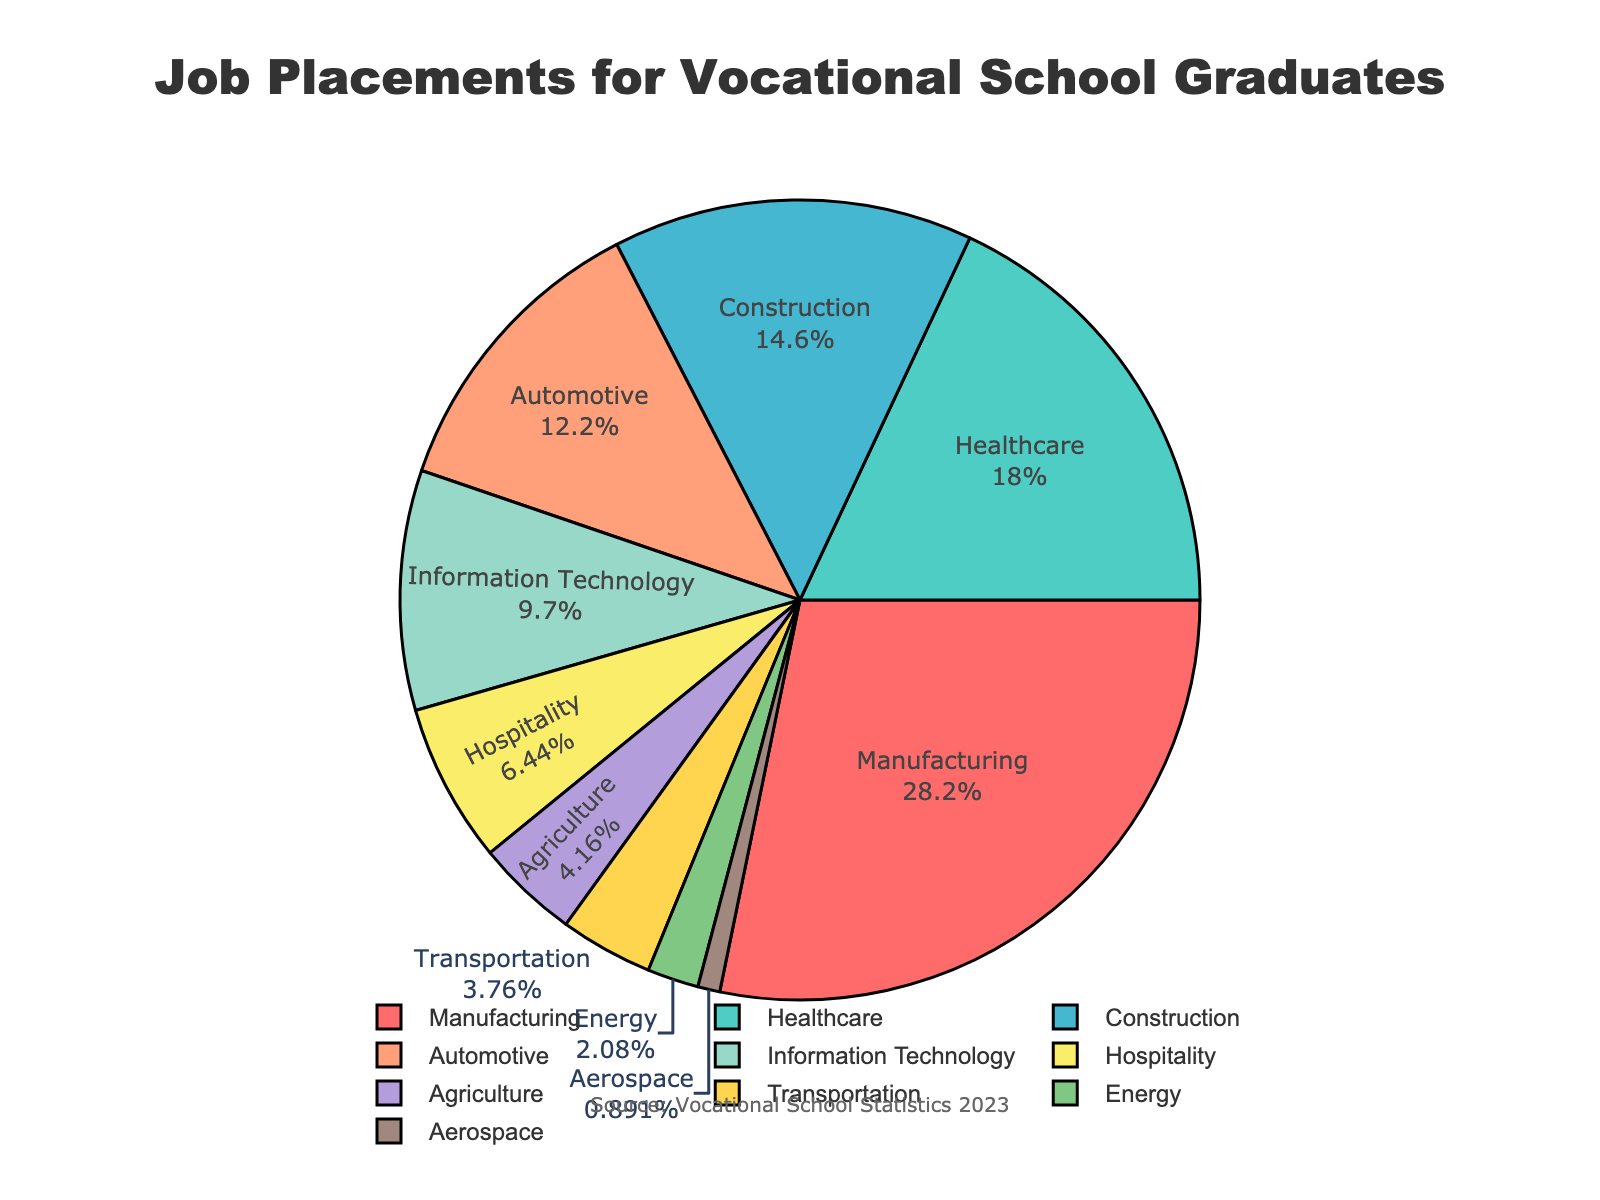What is the largest sector for job placements? The largest sector is identified by the highest percentage in the pie chart. Manufacturing shows the largest slice at 28.5%.
Answer: Manufacturing How many industries have a placement percentage greater than 10%? By looking at the pie chart, we can count the industries with percentages higher than 10%. These are Manufacturing (28.5%), Healthcare (18.2%), Construction (14.7%), and Automotive (12.3%). So, there are 4 industries.
Answer: 4 Which industry has the smallest share of job placements? The smallest sector can be found by identifying the smallest slice in the pie chart. Aerospace shows the smallest slice at 0.9%.
Answer: Aerospace What is the combined percentage of job placements in the Hospitality and Agriculture industries? To get the combined percentage, add the values for Hospitality (6.5%) and Agriculture (4.2%). This sums to 10.7%.
Answer: 10.7% Which sectors have a higher percentage of job placements than Information Technology? The Information Technology sector is at 9.8%. The sectors with higher percentages are Manufacturing (28.5%), Healthcare (18.2%), Construction (14.7%), and Automotive (12.3%).
Answer: Manufacturing, Healthcare, Construction, Automotive What is the difference in job placement percentages between the Manufacturing and Healthcare sectors? Subtract the percentage of Healthcare (18.2%) from Manufacturing (28.5%). The difference is 10.3%.
Answer: 10.3% Rank the top three sectors in terms of job placements. From the pie chart, the top three sectors by percentage are Manufacturing (28.5%), Healthcare (18.2%), and Construction (14.7%).
Answer: Manufacturing, Healthcare, Construction If you combine the percentages of Automotive, Information Technology, and Hospitality sectors, do they together exceed the Manufacturing sector's percentage? First, add the percentages of Automotive (12.3%), Information Technology (9.8%), and Hospitality (6.5%). This equals 28.6%, which exceeds the Manufacturing percentage of 28.5%.
Answer: Yes What percentage of job placements are in sectors other than Manufacturing, Healthcare, and Construction? First, add the percentages of Manufacturing (28.5%), Healthcare (18.2%), and Construction (14.7%). This equals 61.4%. Subtract this from 100% to get the remaining percentage, which is 38.6%.
Answer: 38.6% What is the common color used to represent the Healthcare sector in the pie chart? The Healthcare sector is represented by the slice with a greenish color, specifically the second color in the list.
Answer: Greenish 